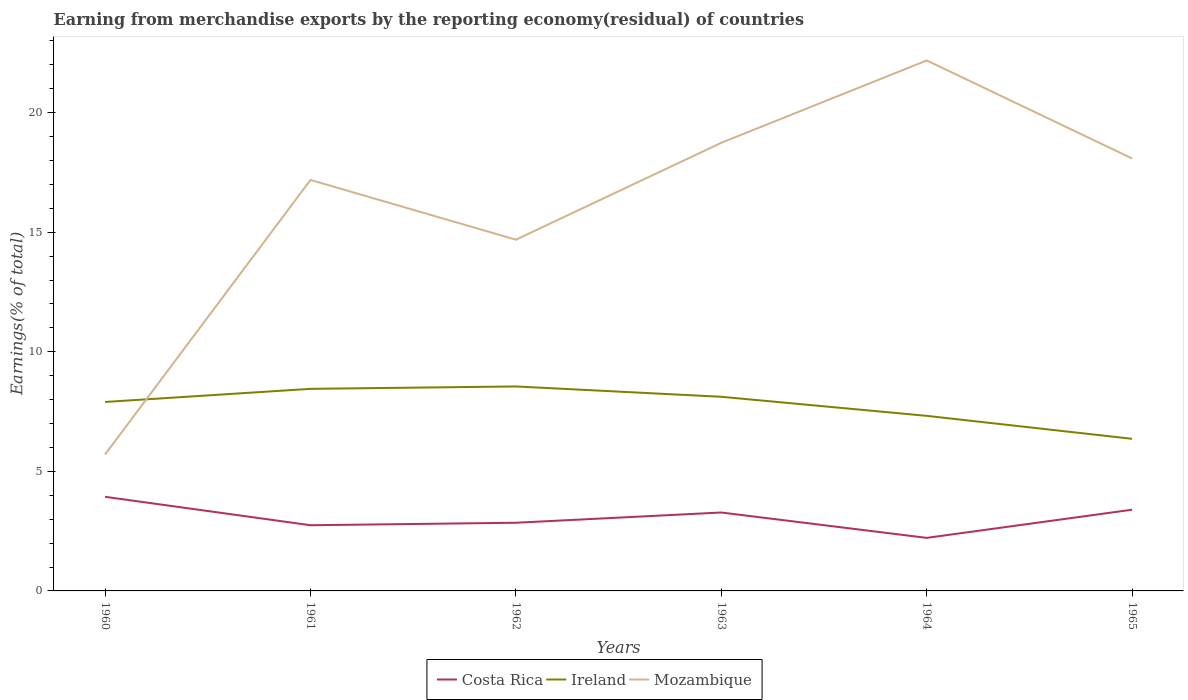Does the line corresponding to Costa Rica intersect with the line corresponding to Ireland?
Your answer should be very brief. No. Is the number of lines equal to the number of legend labels?
Offer a very short reply. Yes. Across all years, what is the maximum percentage of amount earned from merchandise exports in Costa Rica?
Your answer should be compact. 2.22. In which year was the percentage of amount earned from merchandise exports in Mozambique maximum?
Offer a very short reply. 1960. What is the total percentage of amount earned from merchandise exports in Ireland in the graph?
Offer a terse response. 1.76. What is the difference between the highest and the second highest percentage of amount earned from merchandise exports in Ireland?
Your answer should be compact. 2.19. Is the percentage of amount earned from merchandise exports in Ireland strictly greater than the percentage of amount earned from merchandise exports in Costa Rica over the years?
Your answer should be compact. No. How many years are there in the graph?
Ensure brevity in your answer.  6. How many legend labels are there?
Make the answer very short. 3. What is the title of the graph?
Provide a succinct answer. Earning from merchandise exports by the reporting economy(residual) of countries. What is the label or title of the X-axis?
Give a very brief answer. Years. What is the label or title of the Y-axis?
Keep it short and to the point. Earnings(% of total). What is the Earnings(% of total) of Costa Rica in 1960?
Offer a terse response. 3.94. What is the Earnings(% of total) in Ireland in 1960?
Your answer should be compact. 7.9. What is the Earnings(% of total) in Mozambique in 1960?
Ensure brevity in your answer.  5.71. What is the Earnings(% of total) of Costa Rica in 1961?
Offer a very short reply. 2.75. What is the Earnings(% of total) in Ireland in 1961?
Your answer should be compact. 8.45. What is the Earnings(% of total) of Mozambique in 1961?
Your answer should be very brief. 17.18. What is the Earnings(% of total) in Costa Rica in 1962?
Offer a very short reply. 2.85. What is the Earnings(% of total) of Ireland in 1962?
Provide a succinct answer. 8.55. What is the Earnings(% of total) of Mozambique in 1962?
Provide a short and direct response. 14.69. What is the Earnings(% of total) in Costa Rica in 1963?
Offer a terse response. 3.28. What is the Earnings(% of total) in Ireland in 1963?
Your response must be concise. 8.12. What is the Earnings(% of total) of Mozambique in 1963?
Ensure brevity in your answer.  18.74. What is the Earnings(% of total) in Costa Rica in 1964?
Your response must be concise. 2.22. What is the Earnings(% of total) in Ireland in 1964?
Offer a very short reply. 7.32. What is the Earnings(% of total) of Mozambique in 1964?
Keep it short and to the point. 22.18. What is the Earnings(% of total) in Costa Rica in 1965?
Your answer should be compact. 3.4. What is the Earnings(% of total) in Ireland in 1965?
Provide a succinct answer. 6.36. What is the Earnings(% of total) in Mozambique in 1965?
Ensure brevity in your answer.  18.08. Across all years, what is the maximum Earnings(% of total) of Costa Rica?
Make the answer very short. 3.94. Across all years, what is the maximum Earnings(% of total) in Ireland?
Offer a very short reply. 8.55. Across all years, what is the maximum Earnings(% of total) in Mozambique?
Offer a terse response. 22.18. Across all years, what is the minimum Earnings(% of total) in Costa Rica?
Give a very brief answer. 2.22. Across all years, what is the minimum Earnings(% of total) in Ireland?
Your answer should be compact. 6.36. Across all years, what is the minimum Earnings(% of total) of Mozambique?
Provide a succinct answer. 5.71. What is the total Earnings(% of total) of Costa Rica in the graph?
Your answer should be compact. 18.43. What is the total Earnings(% of total) of Ireland in the graph?
Provide a succinct answer. 46.7. What is the total Earnings(% of total) in Mozambique in the graph?
Give a very brief answer. 96.57. What is the difference between the Earnings(% of total) of Costa Rica in 1960 and that in 1961?
Keep it short and to the point. 1.19. What is the difference between the Earnings(% of total) in Ireland in 1960 and that in 1961?
Make the answer very short. -0.55. What is the difference between the Earnings(% of total) in Mozambique in 1960 and that in 1961?
Offer a very short reply. -11.48. What is the difference between the Earnings(% of total) in Costa Rica in 1960 and that in 1962?
Your answer should be very brief. 1.08. What is the difference between the Earnings(% of total) of Ireland in 1960 and that in 1962?
Provide a short and direct response. -0.65. What is the difference between the Earnings(% of total) in Mozambique in 1960 and that in 1962?
Provide a short and direct response. -8.98. What is the difference between the Earnings(% of total) in Costa Rica in 1960 and that in 1963?
Ensure brevity in your answer.  0.66. What is the difference between the Earnings(% of total) in Ireland in 1960 and that in 1963?
Make the answer very short. -0.22. What is the difference between the Earnings(% of total) in Mozambique in 1960 and that in 1963?
Offer a very short reply. -13.03. What is the difference between the Earnings(% of total) in Costa Rica in 1960 and that in 1964?
Offer a very short reply. 1.72. What is the difference between the Earnings(% of total) of Ireland in 1960 and that in 1964?
Keep it short and to the point. 0.58. What is the difference between the Earnings(% of total) of Mozambique in 1960 and that in 1964?
Make the answer very short. -16.47. What is the difference between the Earnings(% of total) of Costa Rica in 1960 and that in 1965?
Offer a very short reply. 0.54. What is the difference between the Earnings(% of total) of Ireland in 1960 and that in 1965?
Offer a very short reply. 1.54. What is the difference between the Earnings(% of total) of Mozambique in 1960 and that in 1965?
Your response must be concise. -12.37. What is the difference between the Earnings(% of total) of Costa Rica in 1961 and that in 1962?
Your response must be concise. -0.1. What is the difference between the Earnings(% of total) in Ireland in 1961 and that in 1962?
Your answer should be very brief. -0.1. What is the difference between the Earnings(% of total) in Mozambique in 1961 and that in 1962?
Provide a short and direct response. 2.5. What is the difference between the Earnings(% of total) of Costa Rica in 1961 and that in 1963?
Provide a succinct answer. -0.53. What is the difference between the Earnings(% of total) of Ireland in 1961 and that in 1963?
Your response must be concise. 0.33. What is the difference between the Earnings(% of total) of Mozambique in 1961 and that in 1963?
Ensure brevity in your answer.  -1.55. What is the difference between the Earnings(% of total) of Costa Rica in 1961 and that in 1964?
Offer a terse response. 0.53. What is the difference between the Earnings(% of total) of Ireland in 1961 and that in 1964?
Your response must be concise. 1.13. What is the difference between the Earnings(% of total) in Mozambique in 1961 and that in 1964?
Keep it short and to the point. -5. What is the difference between the Earnings(% of total) in Costa Rica in 1961 and that in 1965?
Your response must be concise. -0.65. What is the difference between the Earnings(% of total) in Ireland in 1961 and that in 1965?
Offer a terse response. 2.09. What is the difference between the Earnings(% of total) of Mozambique in 1961 and that in 1965?
Ensure brevity in your answer.  -0.9. What is the difference between the Earnings(% of total) in Costa Rica in 1962 and that in 1963?
Your answer should be very brief. -0.43. What is the difference between the Earnings(% of total) in Ireland in 1962 and that in 1963?
Offer a very short reply. 0.43. What is the difference between the Earnings(% of total) in Mozambique in 1962 and that in 1963?
Your answer should be compact. -4.05. What is the difference between the Earnings(% of total) of Costa Rica in 1962 and that in 1964?
Provide a succinct answer. 0.63. What is the difference between the Earnings(% of total) of Ireland in 1962 and that in 1964?
Ensure brevity in your answer.  1.23. What is the difference between the Earnings(% of total) of Mozambique in 1962 and that in 1964?
Offer a terse response. -7.5. What is the difference between the Earnings(% of total) of Costa Rica in 1962 and that in 1965?
Provide a short and direct response. -0.55. What is the difference between the Earnings(% of total) in Ireland in 1962 and that in 1965?
Offer a very short reply. 2.19. What is the difference between the Earnings(% of total) of Mozambique in 1962 and that in 1965?
Provide a succinct answer. -3.4. What is the difference between the Earnings(% of total) in Costa Rica in 1963 and that in 1964?
Ensure brevity in your answer.  1.06. What is the difference between the Earnings(% of total) of Ireland in 1963 and that in 1964?
Offer a terse response. 0.8. What is the difference between the Earnings(% of total) in Mozambique in 1963 and that in 1964?
Ensure brevity in your answer.  -3.44. What is the difference between the Earnings(% of total) of Costa Rica in 1963 and that in 1965?
Offer a very short reply. -0.12. What is the difference between the Earnings(% of total) of Ireland in 1963 and that in 1965?
Give a very brief answer. 1.76. What is the difference between the Earnings(% of total) of Mozambique in 1963 and that in 1965?
Offer a very short reply. 0.66. What is the difference between the Earnings(% of total) in Costa Rica in 1964 and that in 1965?
Your answer should be compact. -1.18. What is the difference between the Earnings(% of total) of Mozambique in 1964 and that in 1965?
Your answer should be very brief. 4.1. What is the difference between the Earnings(% of total) in Costa Rica in 1960 and the Earnings(% of total) in Ireland in 1961?
Keep it short and to the point. -4.51. What is the difference between the Earnings(% of total) of Costa Rica in 1960 and the Earnings(% of total) of Mozambique in 1961?
Keep it short and to the point. -13.25. What is the difference between the Earnings(% of total) of Ireland in 1960 and the Earnings(% of total) of Mozambique in 1961?
Make the answer very short. -9.28. What is the difference between the Earnings(% of total) in Costa Rica in 1960 and the Earnings(% of total) in Ireland in 1962?
Your answer should be very brief. -4.61. What is the difference between the Earnings(% of total) of Costa Rica in 1960 and the Earnings(% of total) of Mozambique in 1962?
Keep it short and to the point. -10.75. What is the difference between the Earnings(% of total) in Ireland in 1960 and the Earnings(% of total) in Mozambique in 1962?
Offer a very short reply. -6.78. What is the difference between the Earnings(% of total) in Costa Rica in 1960 and the Earnings(% of total) in Ireland in 1963?
Make the answer very short. -4.18. What is the difference between the Earnings(% of total) in Costa Rica in 1960 and the Earnings(% of total) in Mozambique in 1963?
Your answer should be very brief. -14.8. What is the difference between the Earnings(% of total) of Ireland in 1960 and the Earnings(% of total) of Mozambique in 1963?
Ensure brevity in your answer.  -10.84. What is the difference between the Earnings(% of total) of Costa Rica in 1960 and the Earnings(% of total) of Ireland in 1964?
Ensure brevity in your answer.  -3.38. What is the difference between the Earnings(% of total) of Costa Rica in 1960 and the Earnings(% of total) of Mozambique in 1964?
Offer a terse response. -18.24. What is the difference between the Earnings(% of total) of Ireland in 1960 and the Earnings(% of total) of Mozambique in 1964?
Your answer should be compact. -14.28. What is the difference between the Earnings(% of total) of Costa Rica in 1960 and the Earnings(% of total) of Ireland in 1965?
Make the answer very short. -2.42. What is the difference between the Earnings(% of total) of Costa Rica in 1960 and the Earnings(% of total) of Mozambique in 1965?
Offer a terse response. -14.14. What is the difference between the Earnings(% of total) in Ireland in 1960 and the Earnings(% of total) in Mozambique in 1965?
Ensure brevity in your answer.  -10.18. What is the difference between the Earnings(% of total) in Costa Rica in 1961 and the Earnings(% of total) in Ireland in 1962?
Your answer should be very brief. -5.8. What is the difference between the Earnings(% of total) of Costa Rica in 1961 and the Earnings(% of total) of Mozambique in 1962?
Ensure brevity in your answer.  -11.94. What is the difference between the Earnings(% of total) in Ireland in 1961 and the Earnings(% of total) in Mozambique in 1962?
Your answer should be very brief. -6.24. What is the difference between the Earnings(% of total) of Costa Rica in 1961 and the Earnings(% of total) of Ireland in 1963?
Keep it short and to the point. -5.37. What is the difference between the Earnings(% of total) in Costa Rica in 1961 and the Earnings(% of total) in Mozambique in 1963?
Provide a succinct answer. -15.99. What is the difference between the Earnings(% of total) in Ireland in 1961 and the Earnings(% of total) in Mozambique in 1963?
Keep it short and to the point. -10.29. What is the difference between the Earnings(% of total) of Costa Rica in 1961 and the Earnings(% of total) of Ireland in 1964?
Your response must be concise. -4.57. What is the difference between the Earnings(% of total) in Costa Rica in 1961 and the Earnings(% of total) in Mozambique in 1964?
Make the answer very short. -19.43. What is the difference between the Earnings(% of total) of Ireland in 1961 and the Earnings(% of total) of Mozambique in 1964?
Your answer should be very brief. -13.73. What is the difference between the Earnings(% of total) in Costa Rica in 1961 and the Earnings(% of total) in Ireland in 1965?
Provide a succinct answer. -3.61. What is the difference between the Earnings(% of total) in Costa Rica in 1961 and the Earnings(% of total) in Mozambique in 1965?
Ensure brevity in your answer.  -15.33. What is the difference between the Earnings(% of total) in Ireland in 1961 and the Earnings(% of total) in Mozambique in 1965?
Ensure brevity in your answer.  -9.63. What is the difference between the Earnings(% of total) of Costa Rica in 1962 and the Earnings(% of total) of Ireland in 1963?
Give a very brief answer. -5.27. What is the difference between the Earnings(% of total) in Costa Rica in 1962 and the Earnings(% of total) in Mozambique in 1963?
Offer a terse response. -15.89. What is the difference between the Earnings(% of total) of Ireland in 1962 and the Earnings(% of total) of Mozambique in 1963?
Offer a very short reply. -10.19. What is the difference between the Earnings(% of total) of Costa Rica in 1962 and the Earnings(% of total) of Ireland in 1964?
Provide a succinct answer. -4.47. What is the difference between the Earnings(% of total) of Costa Rica in 1962 and the Earnings(% of total) of Mozambique in 1964?
Make the answer very short. -19.33. What is the difference between the Earnings(% of total) of Ireland in 1962 and the Earnings(% of total) of Mozambique in 1964?
Keep it short and to the point. -13.63. What is the difference between the Earnings(% of total) of Costa Rica in 1962 and the Earnings(% of total) of Ireland in 1965?
Provide a short and direct response. -3.51. What is the difference between the Earnings(% of total) in Costa Rica in 1962 and the Earnings(% of total) in Mozambique in 1965?
Keep it short and to the point. -15.23. What is the difference between the Earnings(% of total) of Ireland in 1962 and the Earnings(% of total) of Mozambique in 1965?
Offer a terse response. -9.53. What is the difference between the Earnings(% of total) of Costa Rica in 1963 and the Earnings(% of total) of Ireland in 1964?
Your answer should be compact. -4.04. What is the difference between the Earnings(% of total) of Costa Rica in 1963 and the Earnings(% of total) of Mozambique in 1964?
Keep it short and to the point. -18.9. What is the difference between the Earnings(% of total) in Ireland in 1963 and the Earnings(% of total) in Mozambique in 1964?
Offer a very short reply. -14.06. What is the difference between the Earnings(% of total) of Costa Rica in 1963 and the Earnings(% of total) of Ireland in 1965?
Keep it short and to the point. -3.08. What is the difference between the Earnings(% of total) in Costa Rica in 1963 and the Earnings(% of total) in Mozambique in 1965?
Keep it short and to the point. -14.8. What is the difference between the Earnings(% of total) in Ireland in 1963 and the Earnings(% of total) in Mozambique in 1965?
Give a very brief answer. -9.96. What is the difference between the Earnings(% of total) in Costa Rica in 1964 and the Earnings(% of total) in Ireland in 1965?
Ensure brevity in your answer.  -4.14. What is the difference between the Earnings(% of total) in Costa Rica in 1964 and the Earnings(% of total) in Mozambique in 1965?
Provide a short and direct response. -15.86. What is the difference between the Earnings(% of total) in Ireland in 1964 and the Earnings(% of total) in Mozambique in 1965?
Provide a short and direct response. -10.76. What is the average Earnings(% of total) of Costa Rica per year?
Ensure brevity in your answer.  3.07. What is the average Earnings(% of total) in Ireland per year?
Make the answer very short. 7.78. What is the average Earnings(% of total) of Mozambique per year?
Your answer should be compact. 16.1. In the year 1960, what is the difference between the Earnings(% of total) in Costa Rica and Earnings(% of total) in Ireland?
Offer a terse response. -3.97. In the year 1960, what is the difference between the Earnings(% of total) of Costa Rica and Earnings(% of total) of Mozambique?
Your answer should be compact. -1.77. In the year 1960, what is the difference between the Earnings(% of total) in Ireland and Earnings(% of total) in Mozambique?
Make the answer very short. 2.2. In the year 1961, what is the difference between the Earnings(% of total) in Costa Rica and Earnings(% of total) in Ireland?
Make the answer very short. -5.7. In the year 1961, what is the difference between the Earnings(% of total) in Costa Rica and Earnings(% of total) in Mozambique?
Give a very brief answer. -14.44. In the year 1961, what is the difference between the Earnings(% of total) in Ireland and Earnings(% of total) in Mozambique?
Offer a very short reply. -8.73. In the year 1962, what is the difference between the Earnings(% of total) in Costa Rica and Earnings(% of total) in Ireland?
Your response must be concise. -5.7. In the year 1962, what is the difference between the Earnings(% of total) in Costa Rica and Earnings(% of total) in Mozambique?
Offer a terse response. -11.83. In the year 1962, what is the difference between the Earnings(% of total) of Ireland and Earnings(% of total) of Mozambique?
Keep it short and to the point. -6.14. In the year 1963, what is the difference between the Earnings(% of total) in Costa Rica and Earnings(% of total) in Ireland?
Your answer should be compact. -4.84. In the year 1963, what is the difference between the Earnings(% of total) of Costa Rica and Earnings(% of total) of Mozambique?
Provide a short and direct response. -15.46. In the year 1963, what is the difference between the Earnings(% of total) in Ireland and Earnings(% of total) in Mozambique?
Keep it short and to the point. -10.62. In the year 1964, what is the difference between the Earnings(% of total) of Costa Rica and Earnings(% of total) of Ireland?
Provide a succinct answer. -5.1. In the year 1964, what is the difference between the Earnings(% of total) in Costa Rica and Earnings(% of total) in Mozambique?
Your response must be concise. -19.96. In the year 1964, what is the difference between the Earnings(% of total) in Ireland and Earnings(% of total) in Mozambique?
Make the answer very short. -14.86. In the year 1965, what is the difference between the Earnings(% of total) in Costa Rica and Earnings(% of total) in Ireland?
Your answer should be compact. -2.96. In the year 1965, what is the difference between the Earnings(% of total) of Costa Rica and Earnings(% of total) of Mozambique?
Your answer should be very brief. -14.68. In the year 1965, what is the difference between the Earnings(% of total) in Ireland and Earnings(% of total) in Mozambique?
Your answer should be very brief. -11.72. What is the ratio of the Earnings(% of total) of Costa Rica in 1960 to that in 1961?
Make the answer very short. 1.43. What is the ratio of the Earnings(% of total) in Ireland in 1960 to that in 1961?
Offer a very short reply. 0.94. What is the ratio of the Earnings(% of total) of Mozambique in 1960 to that in 1961?
Your answer should be very brief. 0.33. What is the ratio of the Earnings(% of total) in Costa Rica in 1960 to that in 1962?
Offer a terse response. 1.38. What is the ratio of the Earnings(% of total) of Ireland in 1960 to that in 1962?
Give a very brief answer. 0.92. What is the ratio of the Earnings(% of total) of Mozambique in 1960 to that in 1962?
Provide a succinct answer. 0.39. What is the ratio of the Earnings(% of total) in Costa Rica in 1960 to that in 1963?
Make the answer very short. 1.2. What is the ratio of the Earnings(% of total) of Ireland in 1960 to that in 1963?
Offer a terse response. 0.97. What is the ratio of the Earnings(% of total) in Mozambique in 1960 to that in 1963?
Your answer should be compact. 0.3. What is the ratio of the Earnings(% of total) of Costa Rica in 1960 to that in 1964?
Provide a succinct answer. 1.77. What is the ratio of the Earnings(% of total) of Ireland in 1960 to that in 1964?
Your answer should be very brief. 1.08. What is the ratio of the Earnings(% of total) in Mozambique in 1960 to that in 1964?
Give a very brief answer. 0.26. What is the ratio of the Earnings(% of total) of Costa Rica in 1960 to that in 1965?
Give a very brief answer. 1.16. What is the ratio of the Earnings(% of total) in Ireland in 1960 to that in 1965?
Keep it short and to the point. 1.24. What is the ratio of the Earnings(% of total) in Mozambique in 1960 to that in 1965?
Make the answer very short. 0.32. What is the ratio of the Earnings(% of total) of Costa Rica in 1961 to that in 1962?
Provide a succinct answer. 0.96. What is the ratio of the Earnings(% of total) in Ireland in 1961 to that in 1962?
Ensure brevity in your answer.  0.99. What is the ratio of the Earnings(% of total) of Mozambique in 1961 to that in 1962?
Provide a short and direct response. 1.17. What is the ratio of the Earnings(% of total) of Costa Rica in 1961 to that in 1963?
Give a very brief answer. 0.84. What is the ratio of the Earnings(% of total) of Ireland in 1961 to that in 1963?
Your answer should be very brief. 1.04. What is the ratio of the Earnings(% of total) in Mozambique in 1961 to that in 1963?
Offer a very short reply. 0.92. What is the ratio of the Earnings(% of total) of Costa Rica in 1961 to that in 1964?
Offer a very short reply. 1.24. What is the ratio of the Earnings(% of total) in Ireland in 1961 to that in 1964?
Your answer should be very brief. 1.15. What is the ratio of the Earnings(% of total) of Mozambique in 1961 to that in 1964?
Provide a short and direct response. 0.77. What is the ratio of the Earnings(% of total) in Costa Rica in 1961 to that in 1965?
Make the answer very short. 0.81. What is the ratio of the Earnings(% of total) of Ireland in 1961 to that in 1965?
Offer a terse response. 1.33. What is the ratio of the Earnings(% of total) in Mozambique in 1961 to that in 1965?
Offer a terse response. 0.95. What is the ratio of the Earnings(% of total) in Costa Rica in 1962 to that in 1963?
Provide a short and direct response. 0.87. What is the ratio of the Earnings(% of total) of Ireland in 1962 to that in 1963?
Provide a succinct answer. 1.05. What is the ratio of the Earnings(% of total) of Mozambique in 1962 to that in 1963?
Your response must be concise. 0.78. What is the ratio of the Earnings(% of total) of Costa Rica in 1962 to that in 1964?
Your answer should be compact. 1.28. What is the ratio of the Earnings(% of total) of Ireland in 1962 to that in 1964?
Provide a short and direct response. 1.17. What is the ratio of the Earnings(% of total) in Mozambique in 1962 to that in 1964?
Your answer should be very brief. 0.66. What is the ratio of the Earnings(% of total) of Costa Rica in 1962 to that in 1965?
Give a very brief answer. 0.84. What is the ratio of the Earnings(% of total) of Ireland in 1962 to that in 1965?
Your response must be concise. 1.34. What is the ratio of the Earnings(% of total) in Mozambique in 1962 to that in 1965?
Your response must be concise. 0.81. What is the ratio of the Earnings(% of total) in Costa Rica in 1963 to that in 1964?
Your answer should be very brief. 1.48. What is the ratio of the Earnings(% of total) in Ireland in 1963 to that in 1964?
Your response must be concise. 1.11. What is the ratio of the Earnings(% of total) of Mozambique in 1963 to that in 1964?
Make the answer very short. 0.84. What is the ratio of the Earnings(% of total) of Costa Rica in 1963 to that in 1965?
Make the answer very short. 0.97. What is the ratio of the Earnings(% of total) in Ireland in 1963 to that in 1965?
Ensure brevity in your answer.  1.28. What is the ratio of the Earnings(% of total) in Mozambique in 1963 to that in 1965?
Give a very brief answer. 1.04. What is the ratio of the Earnings(% of total) in Costa Rica in 1964 to that in 1965?
Your answer should be very brief. 0.65. What is the ratio of the Earnings(% of total) in Ireland in 1964 to that in 1965?
Your answer should be very brief. 1.15. What is the ratio of the Earnings(% of total) of Mozambique in 1964 to that in 1965?
Make the answer very short. 1.23. What is the difference between the highest and the second highest Earnings(% of total) in Costa Rica?
Your answer should be very brief. 0.54. What is the difference between the highest and the second highest Earnings(% of total) in Ireland?
Ensure brevity in your answer.  0.1. What is the difference between the highest and the second highest Earnings(% of total) of Mozambique?
Your answer should be very brief. 3.44. What is the difference between the highest and the lowest Earnings(% of total) of Costa Rica?
Your response must be concise. 1.72. What is the difference between the highest and the lowest Earnings(% of total) in Ireland?
Offer a terse response. 2.19. What is the difference between the highest and the lowest Earnings(% of total) of Mozambique?
Give a very brief answer. 16.47. 